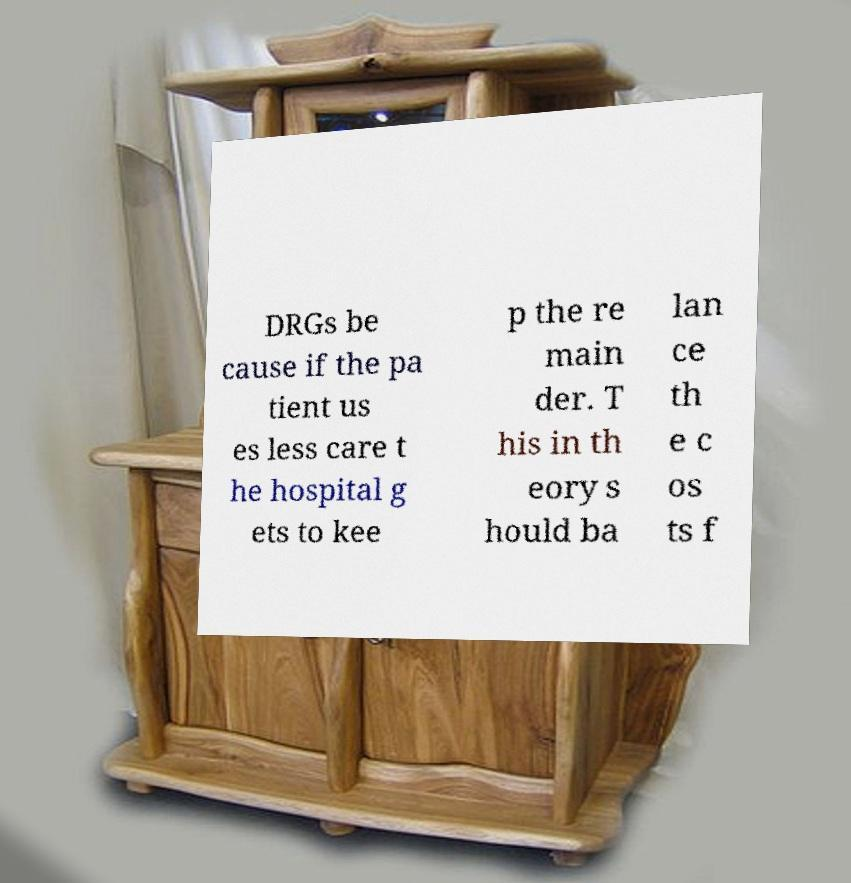Could you assist in decoding the text presented in this image and type it out clearly? DRGs be cause if the pa tient us es less care t he hospital g ets to kee p the re main der. T his in th eory s hould ba lan ce th e c os ts f 